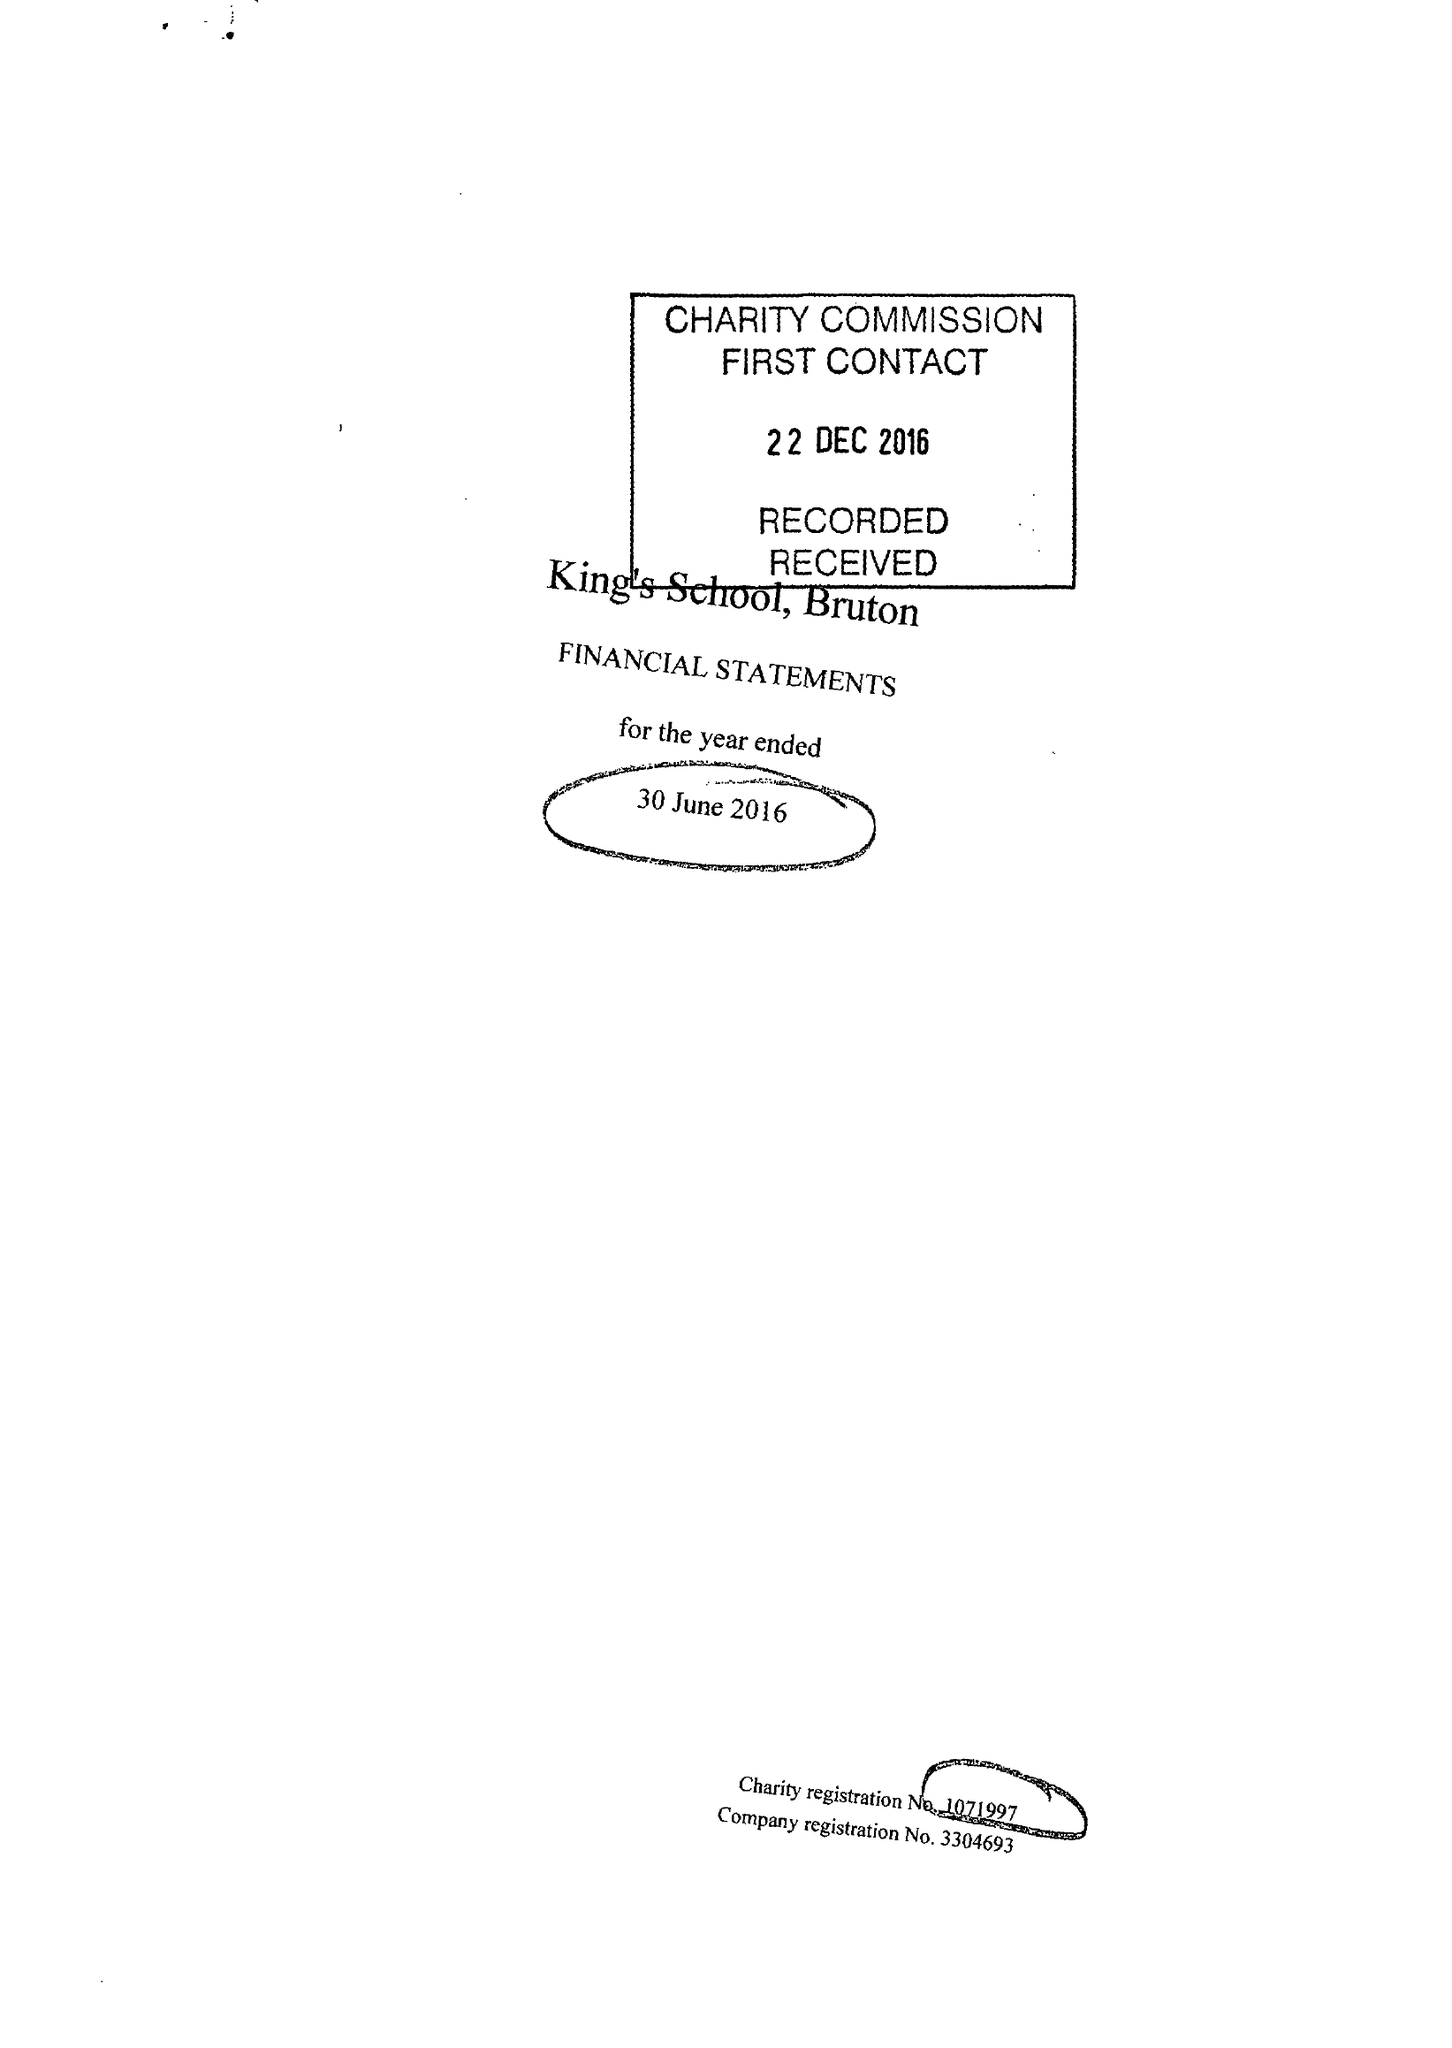What is the value for the charity_number?
Answer the question using a single word or phrase. 1071997 